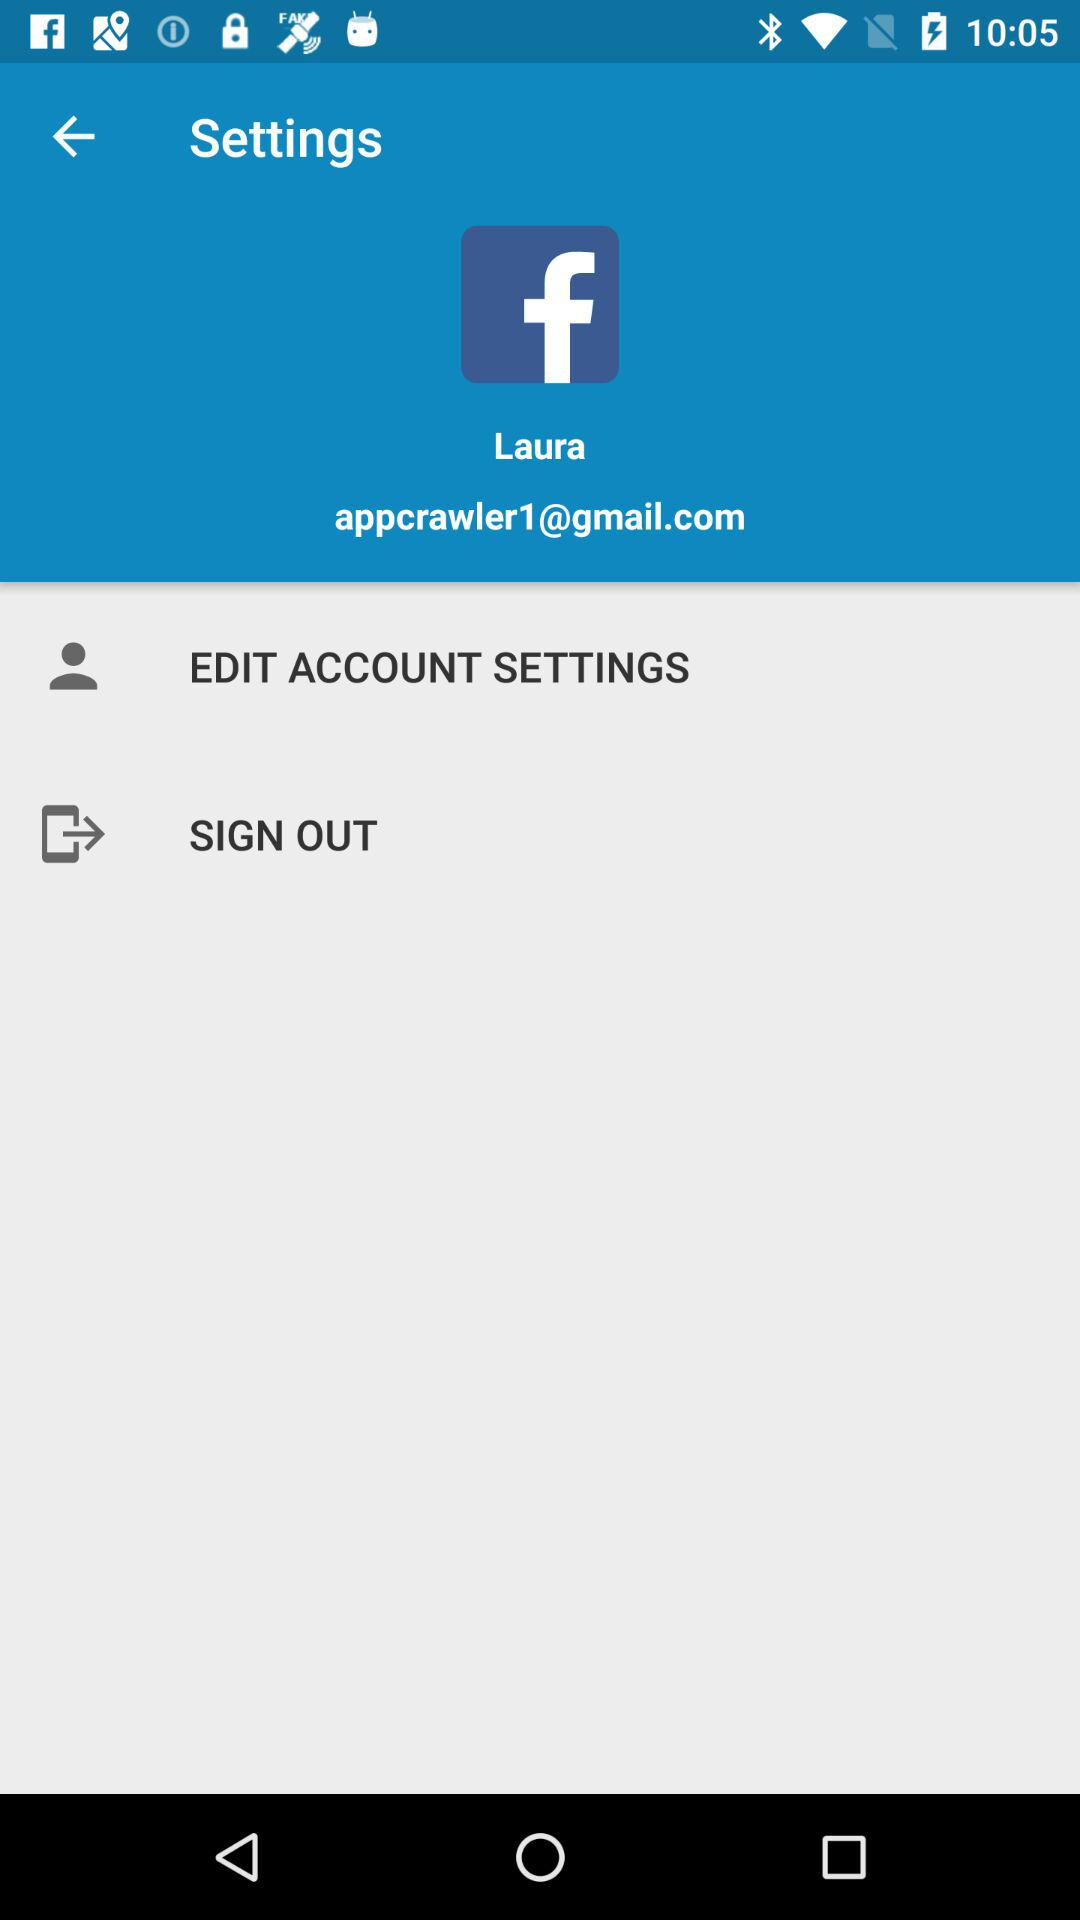What is the email address? The email address is appcrawler1@gmail.com. 